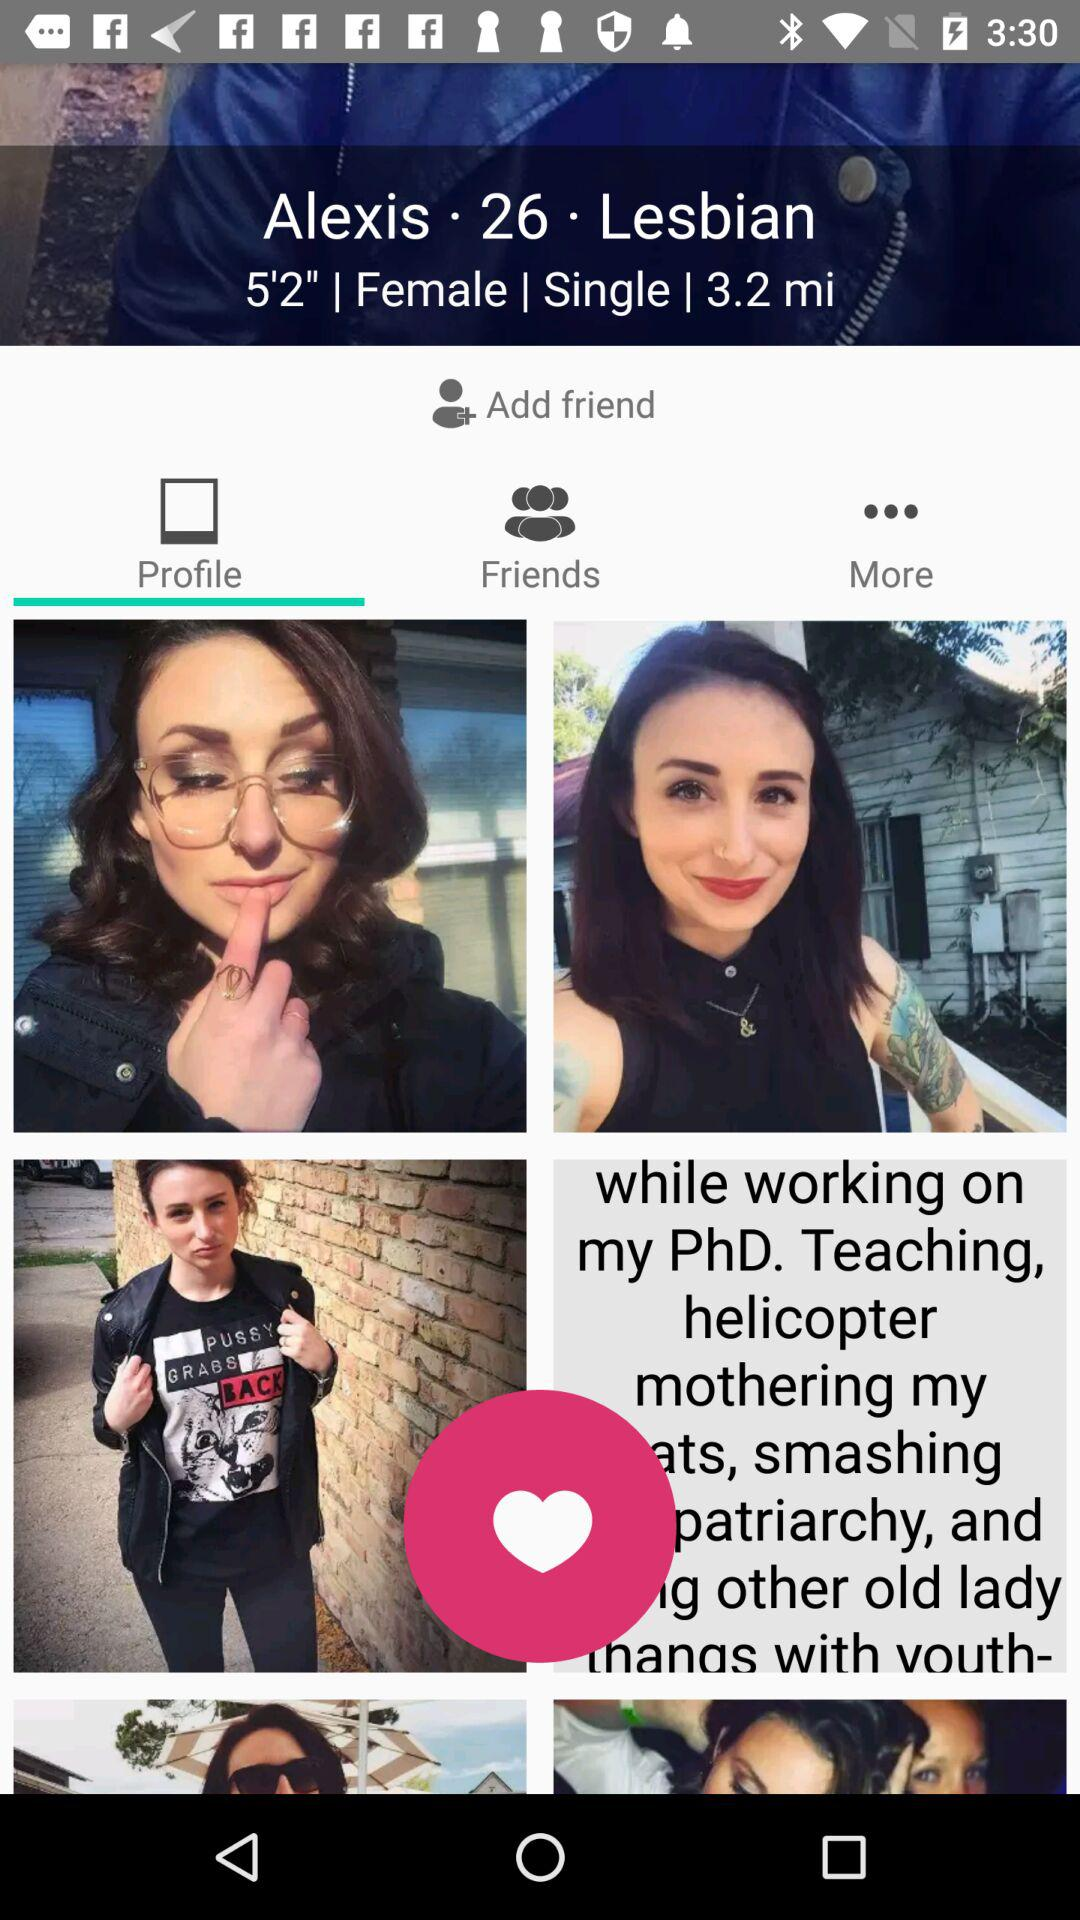What is the gender of Alexis? The gender of Alexis is female. 